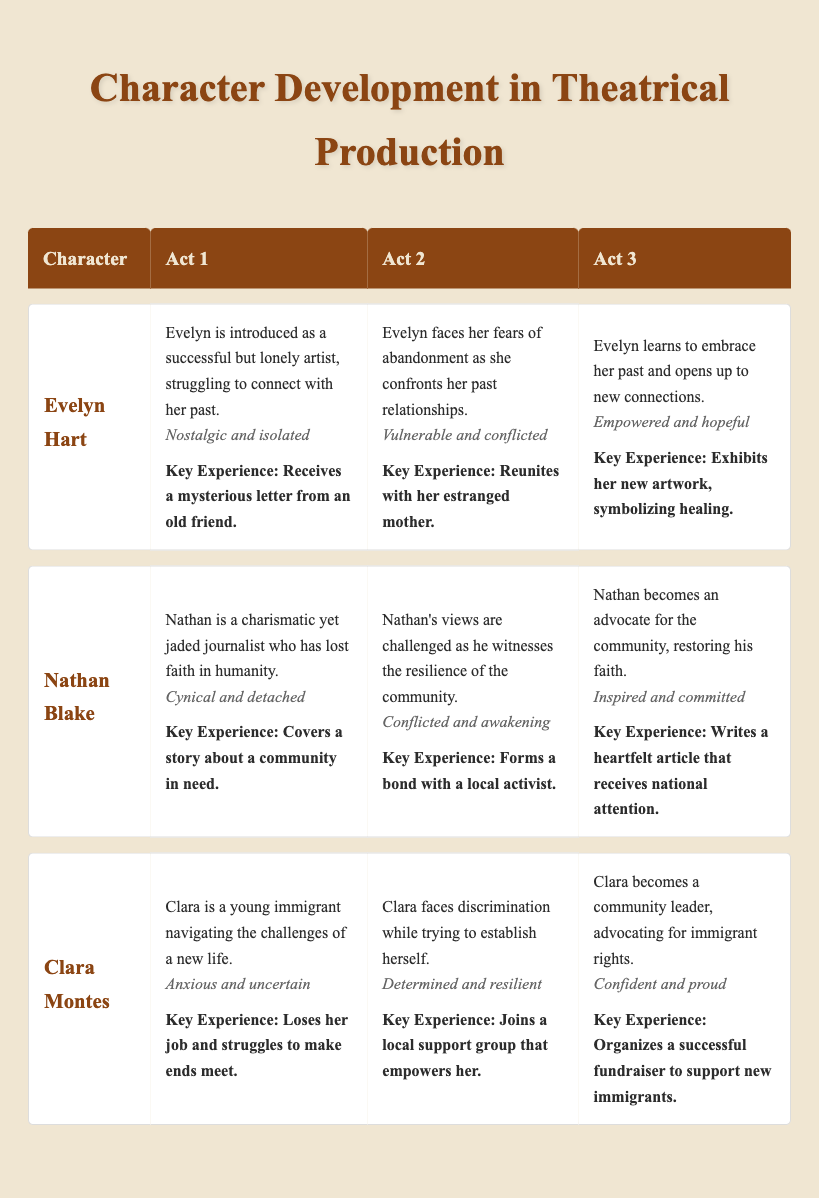What is Clara Montes' emotional state during Act 1? In the table under Clara Montes' Act 1 information, it states her emotional state is "Anxious and uncertain."
Answer: Anxious and uncertain What key experience does Nathan Blake have in Act 2? According to Nathan Blake's information in Act 2, his key experience is "Forms a bond with a local activist."
Answer: Forms a bond with a local activist Which character becomes an advocate for their community by Act 3? Reviewing the Act 3 entries, Clara Montes is noted for "becomes a community leader, advocating for immigrant rights," indicating her advocacy.
Answer: Clara Montes True or False: Evelyn Hart receives a letter that causes her to reflect on her past in Act 1. The table indicates that Evelyn receives a mysterious letter from an old friend, which does prompt her reflection on her past. Therefore, the statement is true.
Answer: True What is the sequence of emotional changes for Evelyn Hart from Act 1 to Act 3? In Act 1, her emotional state is "Nostalgic and isolated," transitioning to "Vulnerable and conflicted" in Act 2, and finally becoming "Empowered and hopeful" in Act 3, showing a progression from isolation to empowerment.
Answer: Nostalgic and isolated → Vulnerable and conflicted → Empowered and hopeful How does Nathan Blake's role change from Act 1 to Act 3? Nathan starts as a "Cynical and detached" journalist in Act 1, faces awakening and conflict in Act 2, and finally becomes "Inspired and committed," indicating a significant transformation to become an advocate for the community.
Answer: From cynical and detached to inspired and committed What is the key experience that signifies Evelyn Hart's healing process in Act 3? In Act 3, Evelyn's key experience of "Exhibits her new artwork, symbolizing healing" reflects her progress and healing journey, marking a significant moment in her character development.
Answer: Exhibits her new artwork, symbolizing healing Is there a character who faces discrimination in Act 2? The table clearly states that Clara Montes experiences discrimination while trying to establish herself in Act 2, confirming that she does face such challenges.
Answer: Yes 